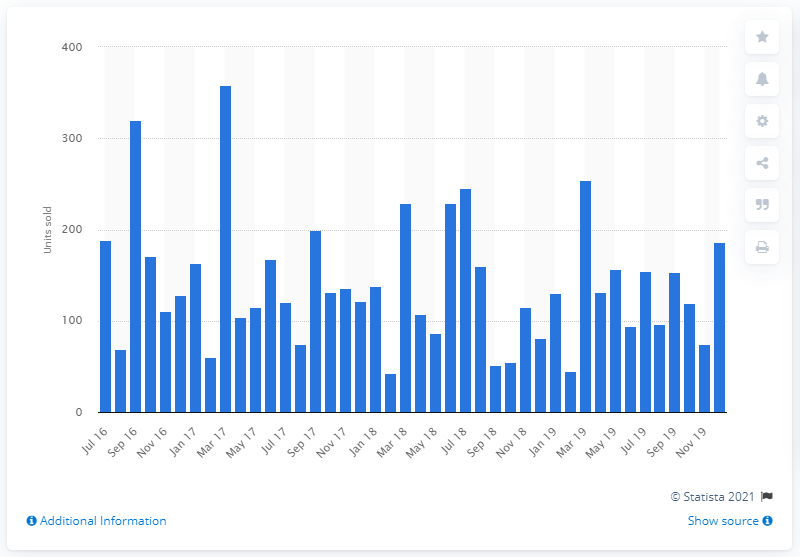Point out several critical features in this image. Bentley sold 186 vehicles in the UK in December 2019. 